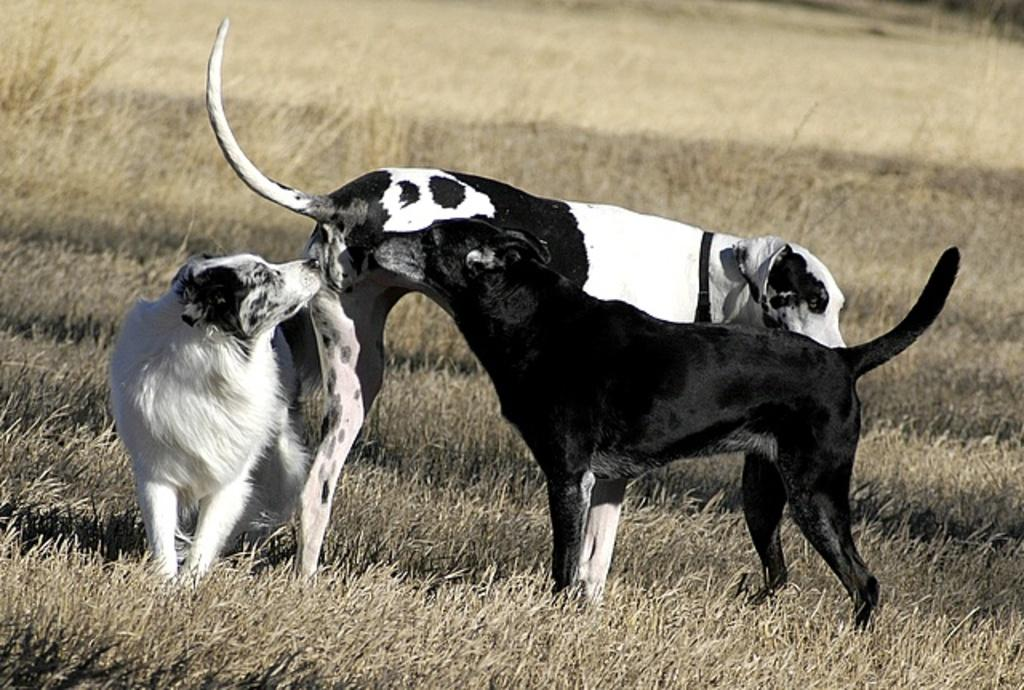How many dogs are in the image? There are three dogs in the image. What colors are the dogs? The dogs are in white and black color. What is the surface the dogs are standing on? The dogs are standing on dried grass. Where is the scarecrow located in the image? There is no scarecrow present in the image. What type of plane can be seen flying in the background of the image? There is no plane visible in the image; it only features three dogs standing on dried grass. 